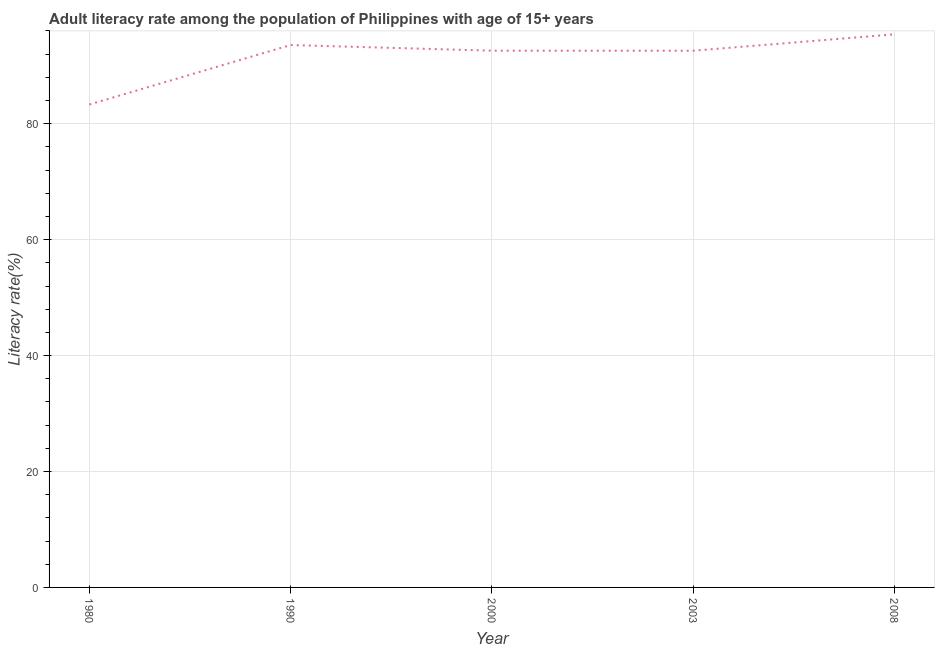What is the adult literacy rate in 2000?
Give a very brief answer. 92.6. Across all years, what is the maximum adult literacy rate?
Keep it short and to the point. 95.42. Across all years, what is the minimum adult literacy rate?
Offer a very short reply. 83.32. In which year was the adult literacy rate maximum?
Give a very brief answer. 2008. What is the sum of the adult literacy rate?
Offer a terse response. 457.5. What is the difference between the adult literacy rate in 2000 and 2003?
Your answer should be compact. 0.01. What is the average adult literacy rate per year?
Make the answer very short. 91.5. What is the median adult literacy rate?
Provide a succinct answer. 92.6. In how many years, is the adult literacy rate greater than 84 %?
Offer a very short reply. 4. Do a majority of the years between 2003 and 1980 (inclusive) have adult literacy rate greater than 48 %?
Offer a very short reply. Yes. What is the ratio of the adult literacy rate in 1990 to that in 2000?
Offer a very short reply. 1.01. Is the adult literacy rate in 1980 less than that in 1990?
Provide a succinct answer. Yes. Is the difference between the adult literacy rate in 1980 and 2008 greater than the difference between any two years?
Give a very brief answer. Yes. What is the difference between the highest and the second highest adult literacy rate?
Your answer should be compact. 1.85. Is the sum of the adult literacy rate in 2003 and 2008 greater than the maximum adult literacy rate across all years?
Provide a short and direct response. Yes. What is the difference between the highest and the lowest adult literacy rate?
Your response must be concise. 12.1. How many lines are there?
Offer a terse response. 1. What is the difference between two consecutive major ticks on the Y-axis?
Offer a terse response. 20. Are the values on the major ticks of Y-axis written in scientific E-notation?
Keep it short and to the point. No. What is the title of the graph?
Give a very brief answer. Adult literacy rate among the population of Philippines with age of 15+ years. What is the label or title of the X-axis?
Make the answer very short. Year. What is the label or title of the Y-axis?
Offer a terse response. Literacy rate(%). What is the Literacy rate(%) in 1980?
Ensure brevity in your answer.  83.32. What is the Literacy rate(%) in 1990?
Give a very brief answer. 93.57. What is the Literacy rate(%) in 2000?
Keep it short and to the point. 92.6. What is the Literacy rate(%) in 2003?
Provide a short and direct response. 92.59. What is the Literacy rate(%) in 2008?
Offer a terse response. 95.42. What is the difference between the Literacy rate(%) in 1980 and 1990?
Your response must be concise. -10.26. What is the difference between the Literacy rate(%) in 1980 and 2000?
Keep it short and to the point. -9.28. What is the difference between the Literacy rate(%) in 1980 and 2003?
Keep it short and to the point. -9.27. What is the difference between the Literacy rate(%) in 1980 and 2008?
Keep it short and to the point. -12.1. What is the difference between the Literacy rate(%) in 1990 and 2000?
Your response must be concise. 0.97. What is the difference between the Literacy rate(%) in 1990 and 2003?
Keep it short and to the point. 0.98. What is the difference between the Literacy rate(%) in 1990 and 2008?
Offer a very short reply. -1.85. What is the difference between the Literacy rate(%) in 2000 and 2003?
Offer a very short reply. 0.01. What is the difference between the Literacy rate(%) in 2000 and 2008?
Provide a short and direct response. -2.82. What is the difference between the Literacy rate(%) in 2003 and 2008?
Your answer should be very brief. -2.83. What is the ratio of the Literacy rate(%) in 1980 to that in 1990?
Provide a short and direct response. 0.89. What is the ratio of the Literacy rate(%) in 1980 to that in 2003?
Offer a terse response. 0.9. What is the ratio of the Literacy rate(%) in 1980 to that in 2008?
Provide a short and direct response. 0.87. What is the ratio of the Literacy rate(%) in 1990 to that in 2008?
Your answer should be very brief. 0.98. 